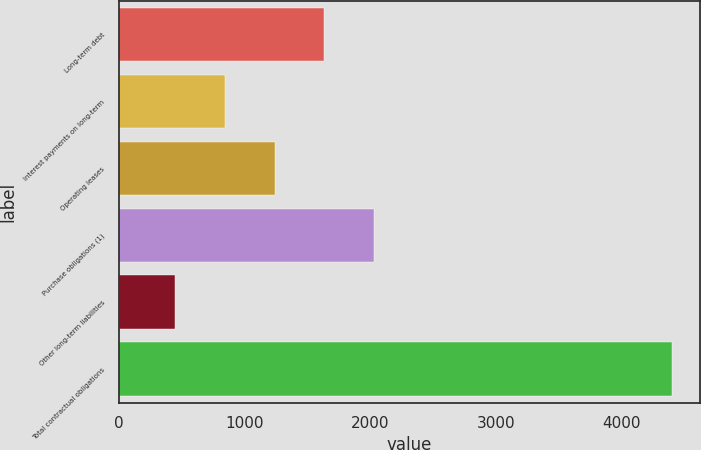Convert chart to OTSL. <chart><loc_0><loc_0><loc_500><loc_500><bar_chart><fcel>Long-term debt<fcel>Interest payments on long-term<fcel>Operating leases<fcel>Purchase obligations (1)<fcel>Other long-term liabilities<fcel>Total contractual obligations<nl><fcel>1634.1<fcel>842.7<fcel>1238.4<fcel>2029.8<fcel>447<fcel>4404<nl></chart> 